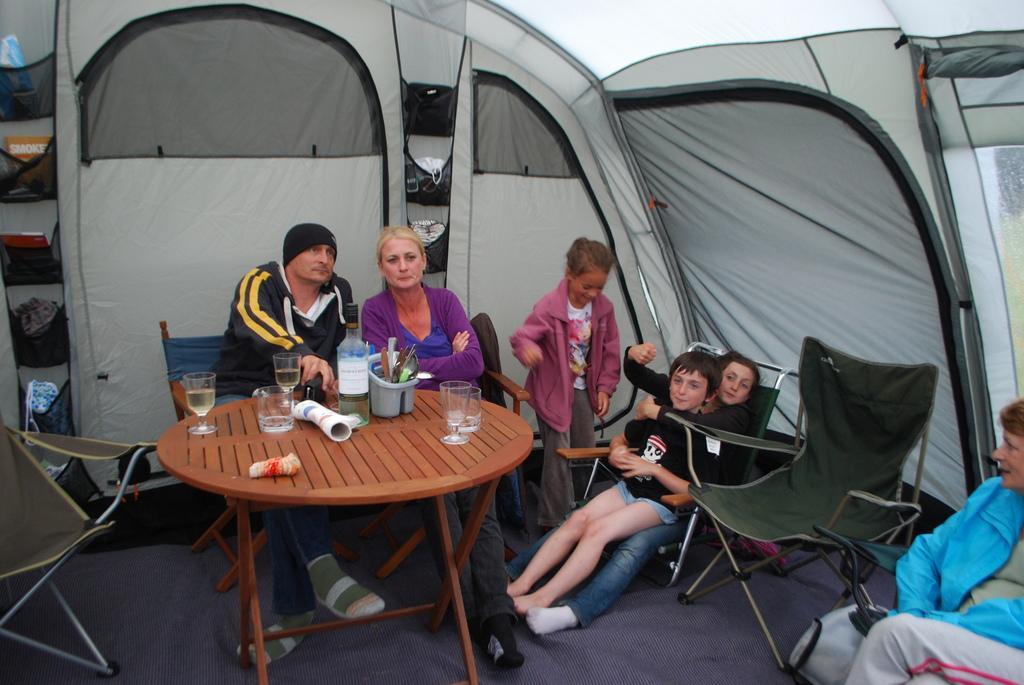Could you give a brief overview of what you see in this image? A picture inside of a tent. This persons are sitting on chair. In this race there are things. On this table there are glasses, bottle and holder. 